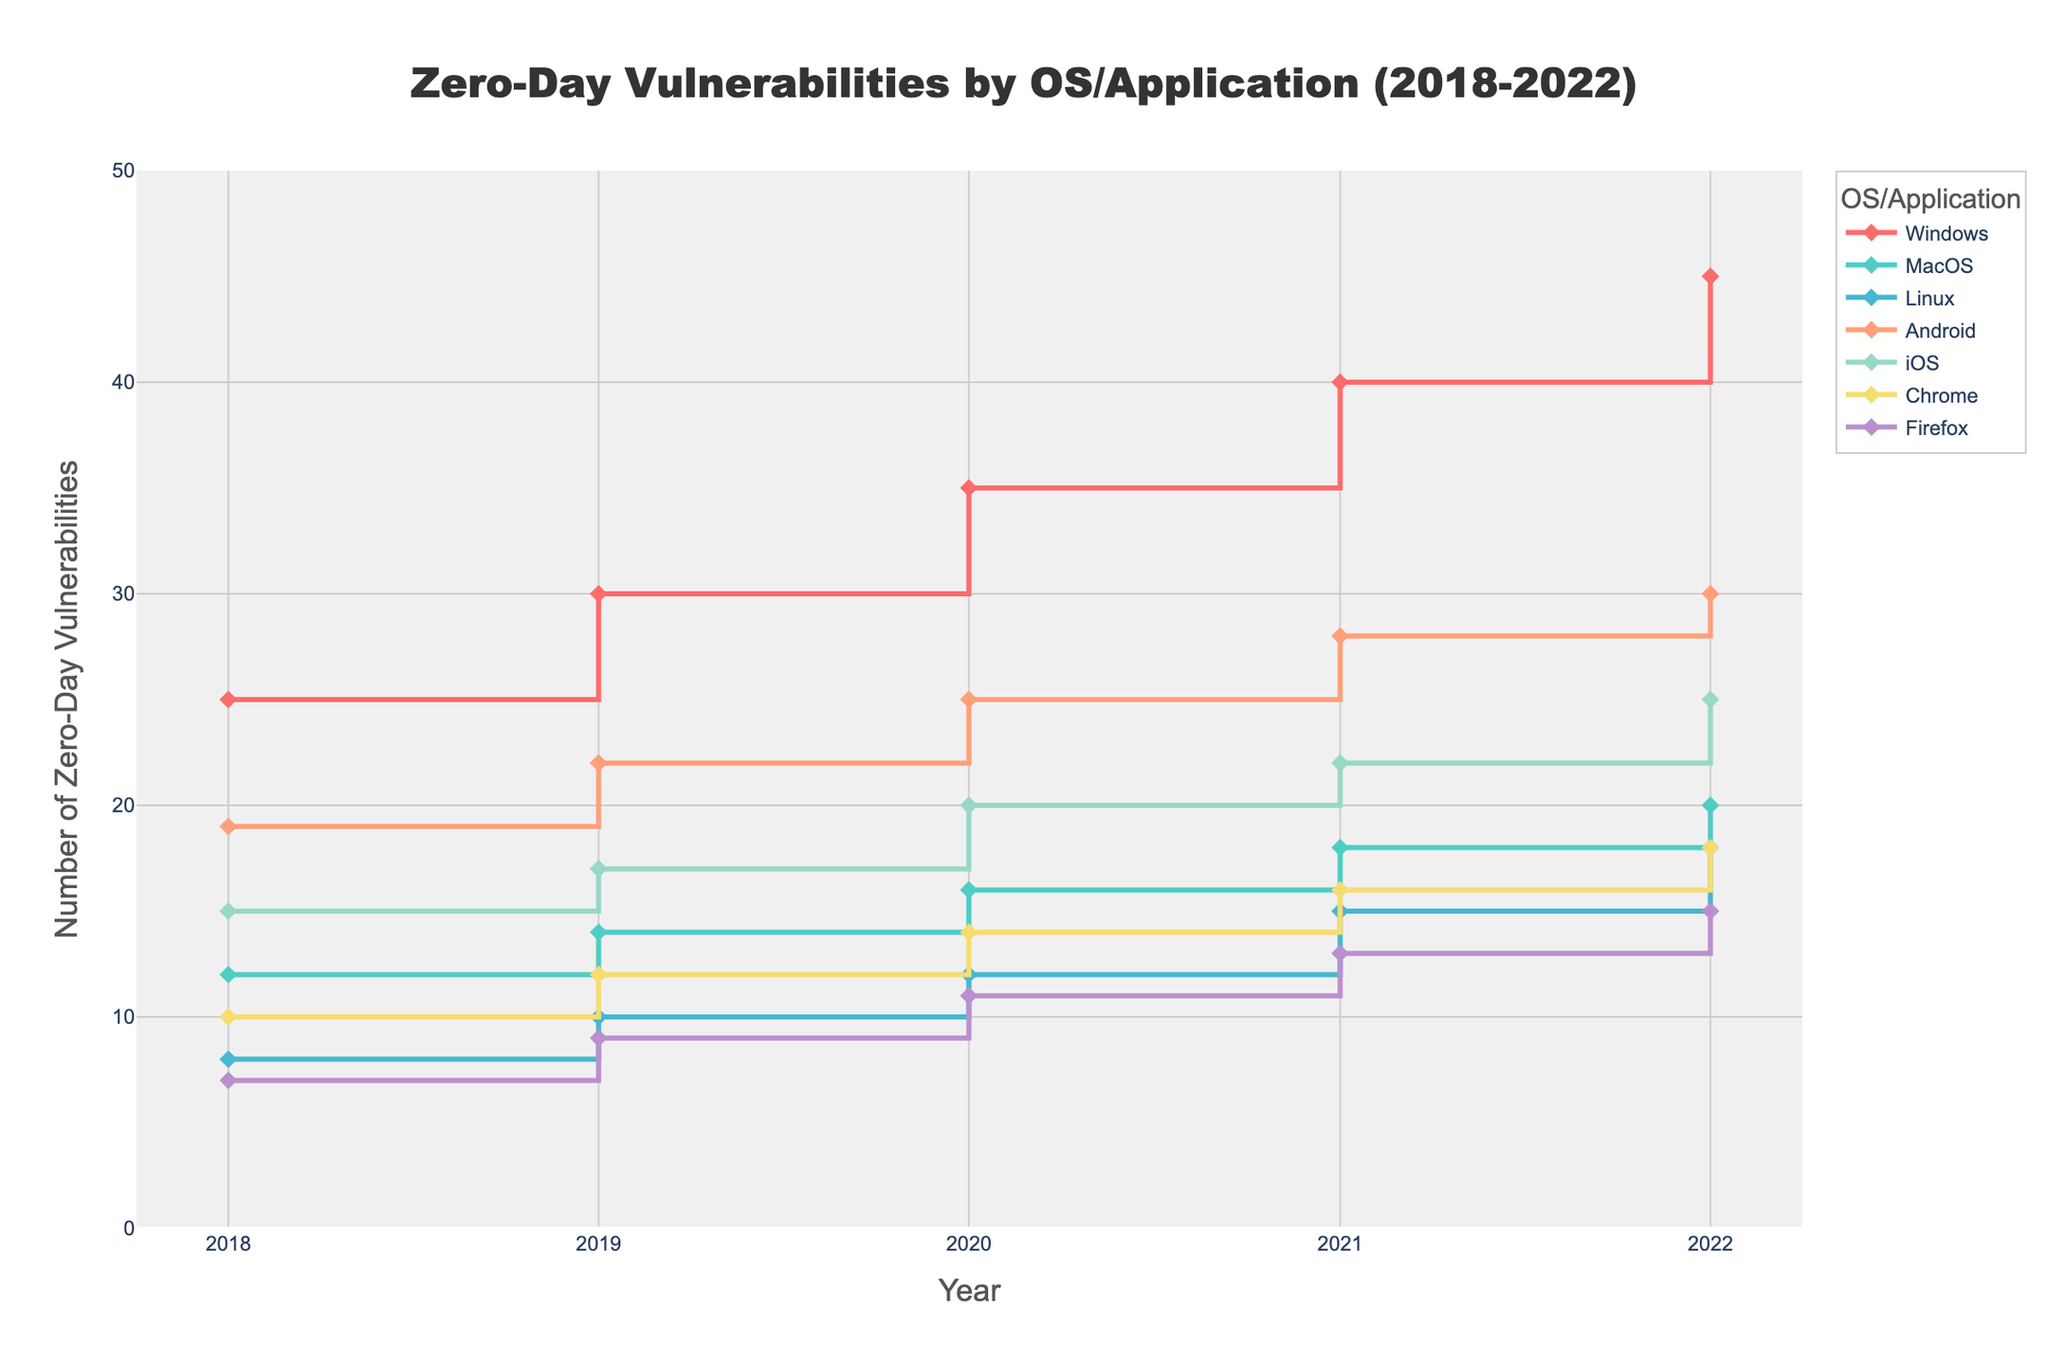What does the title of the plot indicate? The title "Zero-Day Vulnerabilities by OS/Application (2018-2022)" suggests that the plot displays data on the number of zero-day vulnerabilities found each year from 2018 to 2022, categorized by different operating systems and applications.
Answer: Zero-Day Vulnerabilities by OS/Application (2018-2022) Which operating system/application had the highest number of zero-day vulnerabilities in 2019? By looking at the data points for the year 2019, Windows shows the highest count reaching 30 zero-day vulnerabilities.
Answer: Windows How did the number of zero-day vulnerabilities for MacOS change from 2018 to 2022? Observing the values for MacOS, the number increased from 12 in 2018 to 20 in 2022.
Answer: Increased What is the overall trend for the number of zero-day vulnerabilities in Android from 2018 to 2022? The number of zero-day vulnerabilities for Android increased consistently from 19 in 2018 to 30 in 2022.
Answer: Increasing Which operating system/application had the least number of zero-day vulnerabilities in 2020? Reviewing the data points for 2020, Firefox had the least number with 11 zero-day vulnerabilities.
Answer: Firefox Did the number of zero-day vulnerabilities for Chrome increase or decrease from 2020 to 2021? Comparing the data points for Chrome in 2020 and 2021, the number increased from 14 to 16.
Answer: Increased What was the percentage increase in zero-day vulnerabilities for Windows from 2018 to 2022? The number of vulnerabilities in Windows increased from 25 in 2018 to 45 in 2022. The percentage increase is calculated as ((45 - 25) / 25) * 100 = 80%.
Answer: 80% What is the difference in the number of zero-day vulnerabilities between iOS and Android in 2022? In 2022, Android had 30 vulnerabilities and iOS had 25, leading to a difference of 5.
Answer: 5 Which two operating systems/applications had equal numbers of zero-day vulnerabilities in any given year, and what is that number? In 2018, Linux and Firefox both had 7 zero-day vulnerabilities.
Answer: Linux and Firefox, 7 How does the line shape (staircase-like) help in understanding the nature of zero-day vulnerabilities over the years? The staircase-like line shape (step chart) clearly indicates changes per year without interpolation, making it easy to see where and when the number of vulnerabilities increased or leveled off.
Answer: Clear changes per year, indication of increases/level offs 